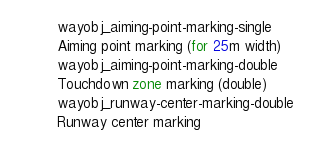<code> <loc_0><loc_0><loc_500><loc_500><_SQL_>wayobj_aiming-point-marking-single
Aiming point marking (for 25m width)
wayobj_aiming-point-marking-double
Touchdown zone marking (double)
wayobj_runway-center-marking-double
Runway center marking
</code> 